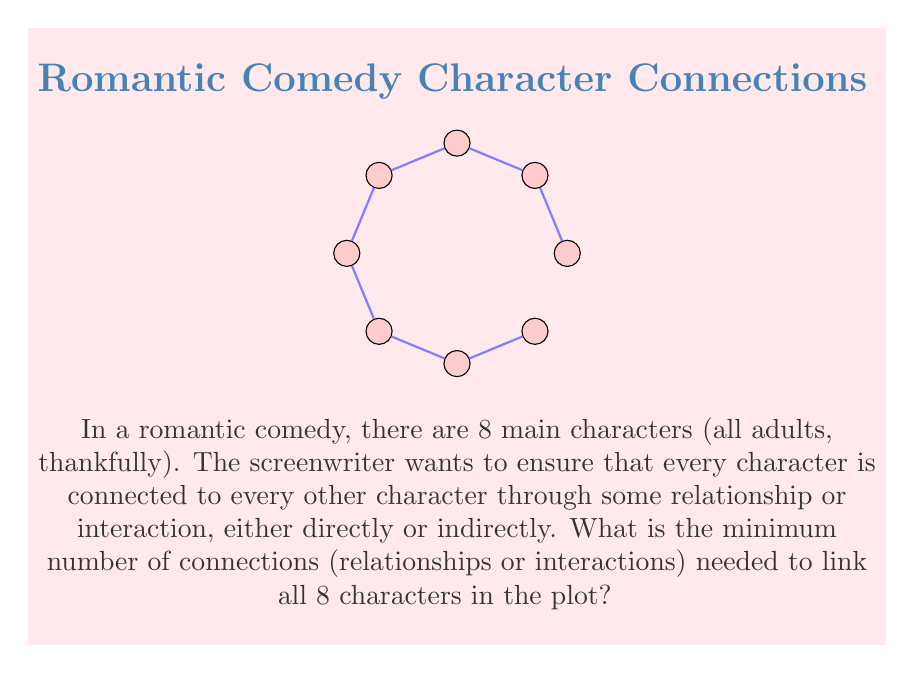Provide a solution to this math problem. To solve this problem, we can use the concept of a minimum spanning tree in graph theory. Here's the step-by-step explanation:

1) In graph theory, a tree is a connected graph with no cycles. A spanning tree of a graph is a tree that includes all vertices of the graph.

2) The minimum number of connections needed to link all characters is equal to the number of edges in a spanning tree of the complete graph on 8 vertices.

3) A key property of trees is that for a tree with $n$ vertices, the number of edges is always $n-1$.

4) In our case, we have 8 characters (vertices), so the minimum number of connections (edges) needed is:

   $$8 - 1 = 7$$

5) This configuration ensures that all characters are connected, either directly or indirectly, with the minimum number of connections.

6) Visually, this could be represented as a tree-like structure where each character is a node, and the 7 connections are the edges linking these nodes.

7) It's worth noting that while there are many possible ways to arrange these 7 connections, the minimum number remains the same regardless of the specific arrangement.
Answer: 7 connections 